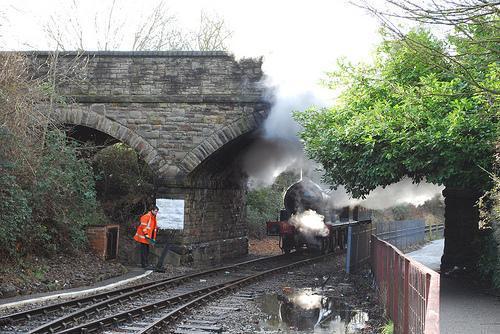How many trains in the train tracks?
Give a very brief answer. 1. 